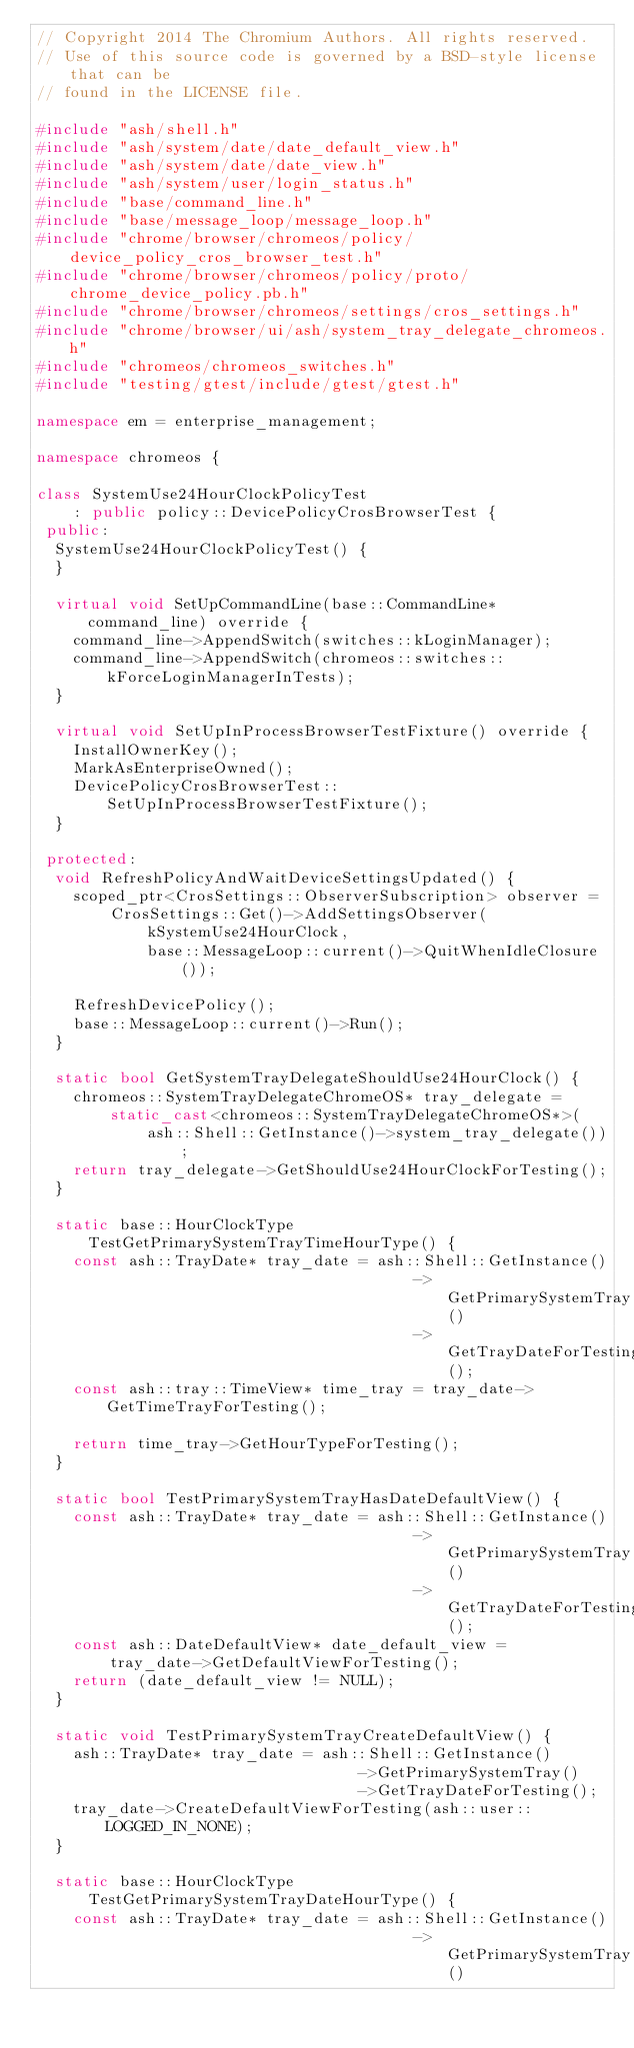Convert code to text. <code><loc_0><loc_0><loc_500><loc_500><_C++_>// Copyright 2014 The Chromium Authors. All rights reserved.
// Use of this source code is governed by a BSD-style license that can be
// found in the LICENSE file.

#include "ash/shell.h"
#include "ash/system/date/date_default_view.h"
#include "ash/system/date/date_view.h"
#include "ash/system/user/login_status.h"
#include "base/command_line.h"
#include "base/message_loop/message_loop.h"
#include "chrome/browser/chromeos/policy/device_policy_cros_browser_test.h"
#include "chrome/browser/chromeos/policy/proto/chrome_device_policy.pb.h"
#include "chrome/browser/chromeos/settings/cros_settings.h"
#include "chrome/browser/ui/ash/system_tray_delegate_chromeos.h"
#include "chromeos/chromeos_switches.h"
#include "testing/gtest/include/gtest/gtest.h"

namespace em = enterprise_management;

namespace chromeos {

class SystemUse24HourClockPolicyTest
    : public policy::DevicePolicyCrosBrowserTest {
 public:
  SystemUse24HourClockPolicyTest() {
  }

  virtual void SetUpCommandLine(base::CommandLine* command_line) override {
    command_line->AppendSwitch(switches::kLoginManager);
    command_line->AppendSwitch(chromeos::switches::kForceLoginManagerInTests);
  }

  virtual void SetUpInProcessBrowserTestFixture() override {
    InstallOwnerKey();
    MarkAsEnterpriseOwned();
    DevicePolicyCrosBrowserTest::SetUpInProcessBrowserTestFixture();
  }

 protected:
  void RefreshPolicyAndWaitDeviceSettingsUpdated() {
    scoped_ptr<CrosSettings::ObserverSubscription> observer =
        CrosSettings::Get()->AddSettingsObserver(
            kSystemUse24HourClock,
            base::MessageLoop::current()->QuitWhenIdleClosure());

    RefreshDevicePolicy();
    base::MessageLoop::current()->Run();
  }

  static bool GetSystemTrayDelegateShouldUse24HourClock() {
    chromeos::SystemTrayDelegateChromeOS* tray_delegate =
        static_cast<chromeos::SystemTrayDelegateChromeOS*>(
            ash::Shell::GetInstance()->system_tray_delegate());
    return tray_delegate->GetShouldUse24HourClockForTesting();
  }

  static base::HourClockType TestGetPrimarySystemTrayTimeHourType() {
    const ash::TrayDate* tray_date = ash::Shell::GetInstance()
                                         ->GetPrimarySystemTray()
                                         ->GetTrayDateForTesting();
    const ash::tray::TimeView* time_tray = tray_date->GetTimeTrayForTesting();

    return time_tray->GetHourTypeForTesting();
  }

  static bool TestPrimarySystemTrayHasDateDefaultView() {
    const ash::TrayDate* tray_date = ash::Shell::GetInstance()
                                         ->GetPrimarySystemTray()
                                         ->GetTrayDateForTesting();
    const ash::DateDefaultView* date_default_view =
        tray_date->GetDefaultViewForTesting();
    return (date_default_view != NULL);
  }

  static void TestPrimarySystemTrayCreateDefaultView() {
    ash::TrayDate* tray_date = ash::Shell::GetInstance()
                                   ->GetPrimarySystemTray()
                                   ->GetTrayDateForTesting();
    tray_date->CreateDefaultViewForTesting(ash::user::LOGGED_IN_NONE);
  }

  static base::HourClockType TestGetPrimarySystemTrayDateHourType() {
    const ash::TrayDate* tray_date = ash::Shell::GetInstance()
                                         ->GetPrimarySystemTray()</code> 